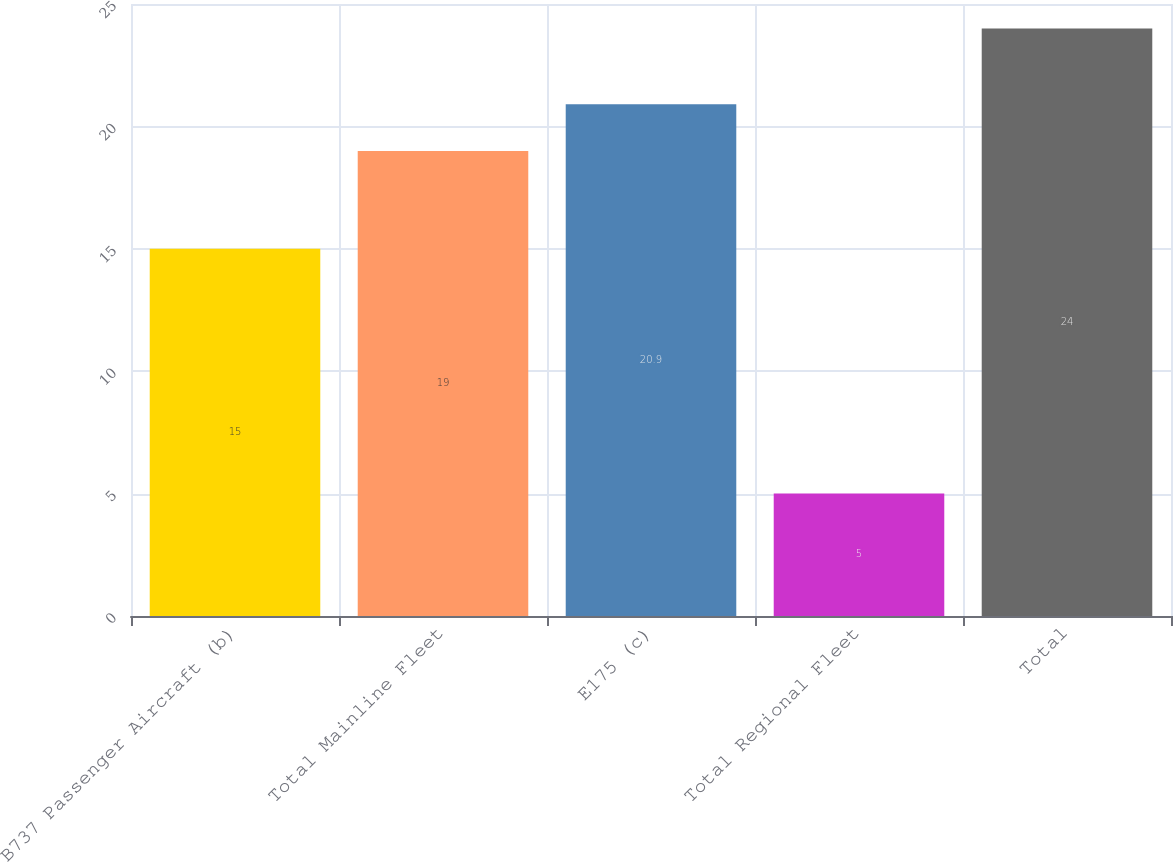<chart> <loc_0><loc_0><loc_500><loc_500><bar_chart><fcel>B737 Passenger Aircraft (b)<fcel>Total Mainline Fleet<fcel>E175 (c)<fcel>Total Regional Fleet<fcel>Total<nl><fcel>15<fcel>19<fcel>20.9<fcel>5<fcel>24<nl></chart> 